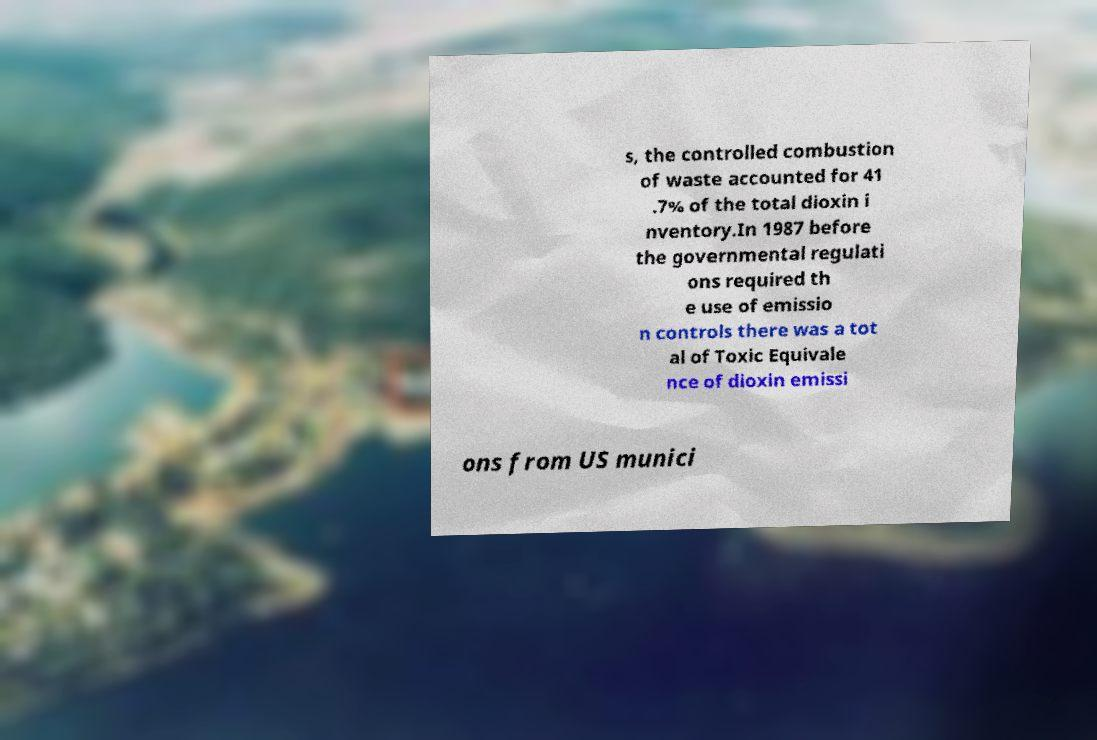I need the written content from this picture converted into text. Can you do that? s, the controlled combustion of waste accounted for 41 .7% of the total dioxin i nventory.In 1987 before the governmental regulati ons required th e use of emissio n controls there was a tot al of Toxic Equivale nce of dioxin emissi ons from US munici 